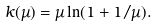<formula> <loc_0><loc_0><loc_500><loc_500>k ( \mu ) = \mu \ln ( 1 + 1 / \mu ) .</formula> 